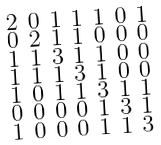Convert formula to latex. <formula><loc_0><loc_0><loc_500><loc_500>\begin{smallmatrix} 2 & 0 & 1 & 1 & 1 & 0 & 1 \\ 0 & 2 & 1 & 1 & 0 & 0 & 0 \\ 1 & 1 & 3 & 1 & 1 & 0 & 0 \\ 1 & 1 & 1 & 3 & 1 & 0 & 0 \\ 1 & 0 & 1 & 1 & 3 & 1 & 1 \\ 0 & 0 & 0 & 0 & 1 & 3 & 1 \\ 1 & 0 & 0 & 0 & 1 & 1 & 3 \end{smallmatrix}</formula> 